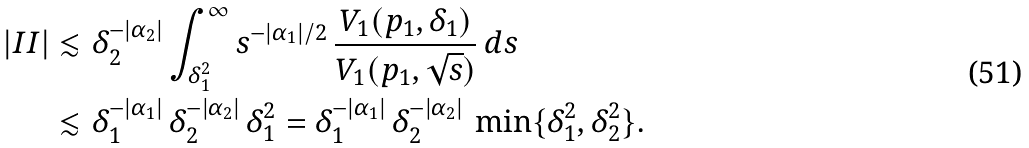<formula> <loc_0><loc_0><loc_500><loc_500>\left | I I \right | & \lesssim \delta _ { 2 } ^ { - | \alpha _ { 2 } | } \int _ { \delta _ { 1 } ^ { 2 } } ^ { \infty } s ^ { - | \alpha _ { 1 } | / 2 } \, \frac { V _ { 1 } ( p _ { 1 } , \delta _ { 1 } ) } { V _ { 1 } ( p _ { 1 } , \sqrt { s } ) } \, d s \\ & \lesssim \delta _ { 1 } ^ { - | \alpha _ { 1 } | } \, \delta _ { 2 } ^ { - | \alpha _ { 2 } | } \, \delta _ { 1 } ^ { 2 } = \delta _ { 1 } ^ { - | \alpha _ { 1 } | } \, \delta _ { 2 } ^ { - | \alpha _ { 2 } | } \, \min \{ \delta _ { 1 } ^ { 2 } , \delta _ { 2 } ^ { 2 } \} .</formula> 